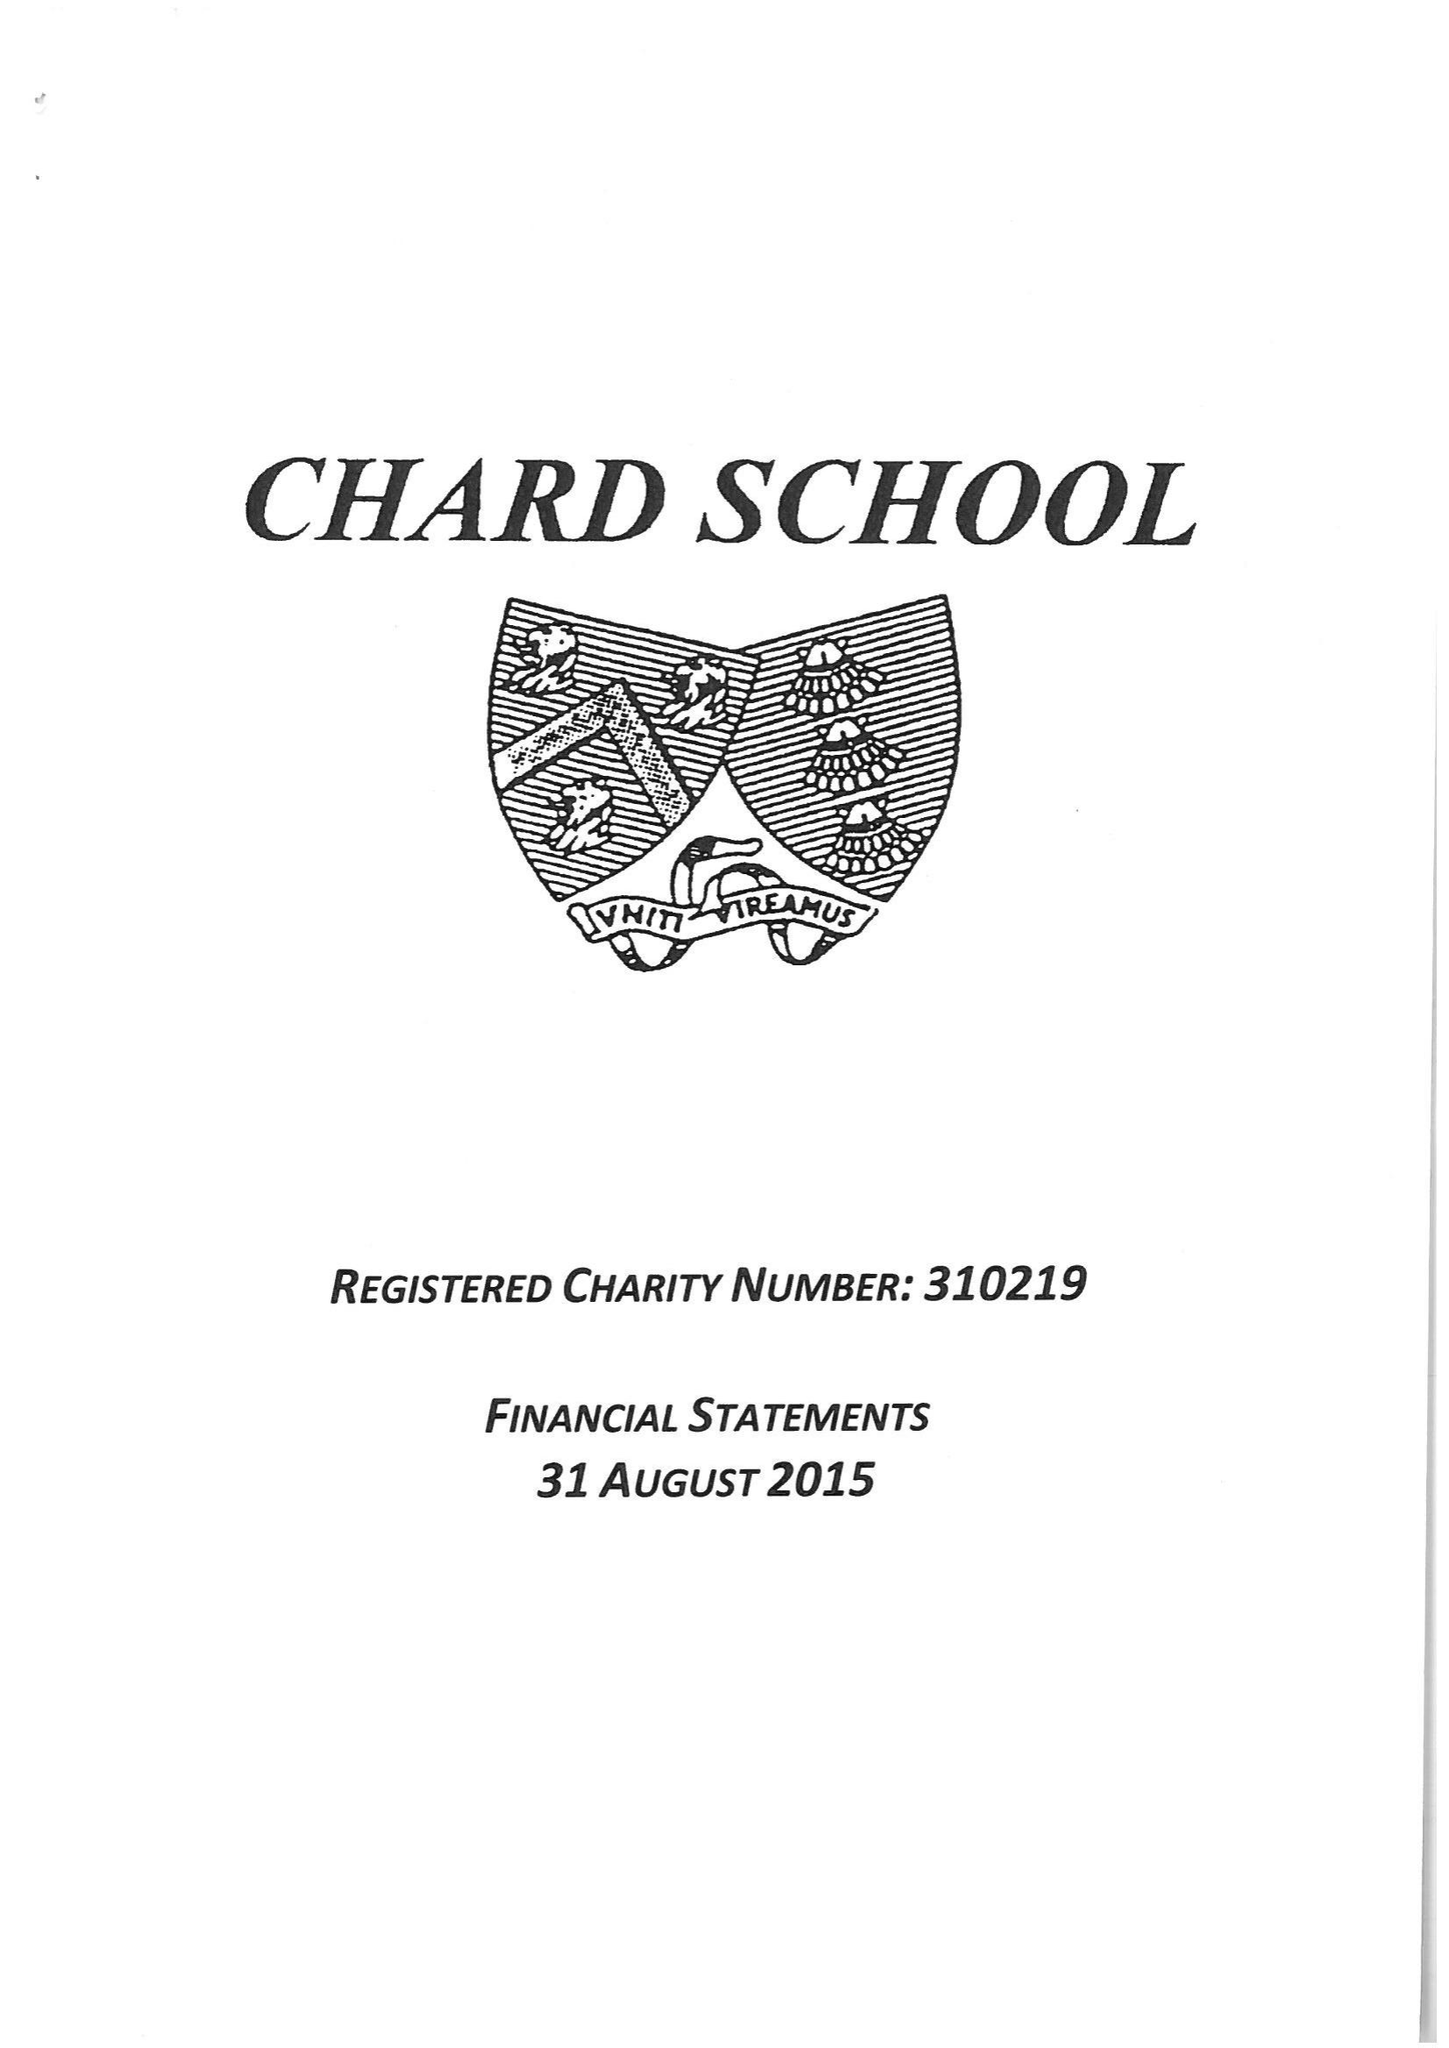What is the value for the address__street_line?
Answer the question using a single word or phrase. FORE STREET 